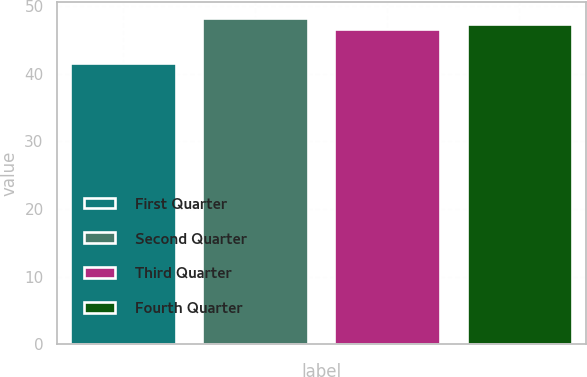Convert chart. <chart><loc_0><loc_0><loc_500><loc_500><bar_chart><fcel>First Quarter<fcel>Second Quarter<fcel>Third Quarter<fcel>Fourth Quarter<nl><fcel>41.58<fcel>48.18<fcel>46.69<fcel>47.4<nl></chart> 